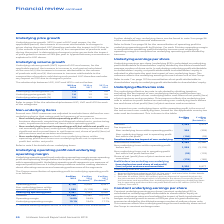According to Unilever Plc's financial document, What does the underlying effective tax rate measure reflects? reflects the underlying tax rate in relation to profit before tax excluding non-underlying items before tax and share of net profit/(loss) of joint ventures and associates.. The document states: "ss) of joint ventures and associates. This measure reflects the underlying tax rate in relation to profit before tax excluding non-underlying items be..." Also, How is the underlying effective tax rate calculated? dividing taxation excluding the tax impact of non-underlying items by profit before tax excluding the impact of non-underlying items and share of net profit/(loss) of joint ventures and associates. The document states: "he underlying effective tax rate is calculated by dividing taxation excluding the tax impact of non-underlying items by profit before tax excluding th..." Also, How is the tax impact on non underlying items within operating profit calculated? sum of the tax on each non-underlying item, based on the applicable country tax rates and tax treatment. The document states: "n-underlying items within operating profit is the sum of the tax on each non-underlying item, based on the applicable country tax rates and tax treatm..." Also, can you calculate: What is the increase / (decrease) in Profit before taxation from 2018 to 2019? Based on the calculation: 8,289 - 12,360, the result is -4071 (in millions). This is based on the information: "Profit before taxation 8,289 12,360 Profit before taxation 8,289 12,360..." The key data points involved are: 12,360, 8,289. Also, can you calculate: What is the Underlying effective tax rate change from 2018 to 2019? Based on the calculation: 25.5 - 25.7, the result is -0.2 (percentage). This is based on the information: "Underlying effective tax rate 25.5% 25.7% Underlying effective tax rate 25.5% 25.7%..." The key data points involved are: 25.5, 25.7. Also, can you calculate: What is the average taxation? To answer this question, I need to perform calculations using the financial data. The calculation is: (2,263 + 2,572) / 2, which equals 2417.5 (in millions). This is based on the information: "Taxation 2,263 2,572 Taxation 2,263 2,572..." The key data points involved are: 2,263, 2,572. 